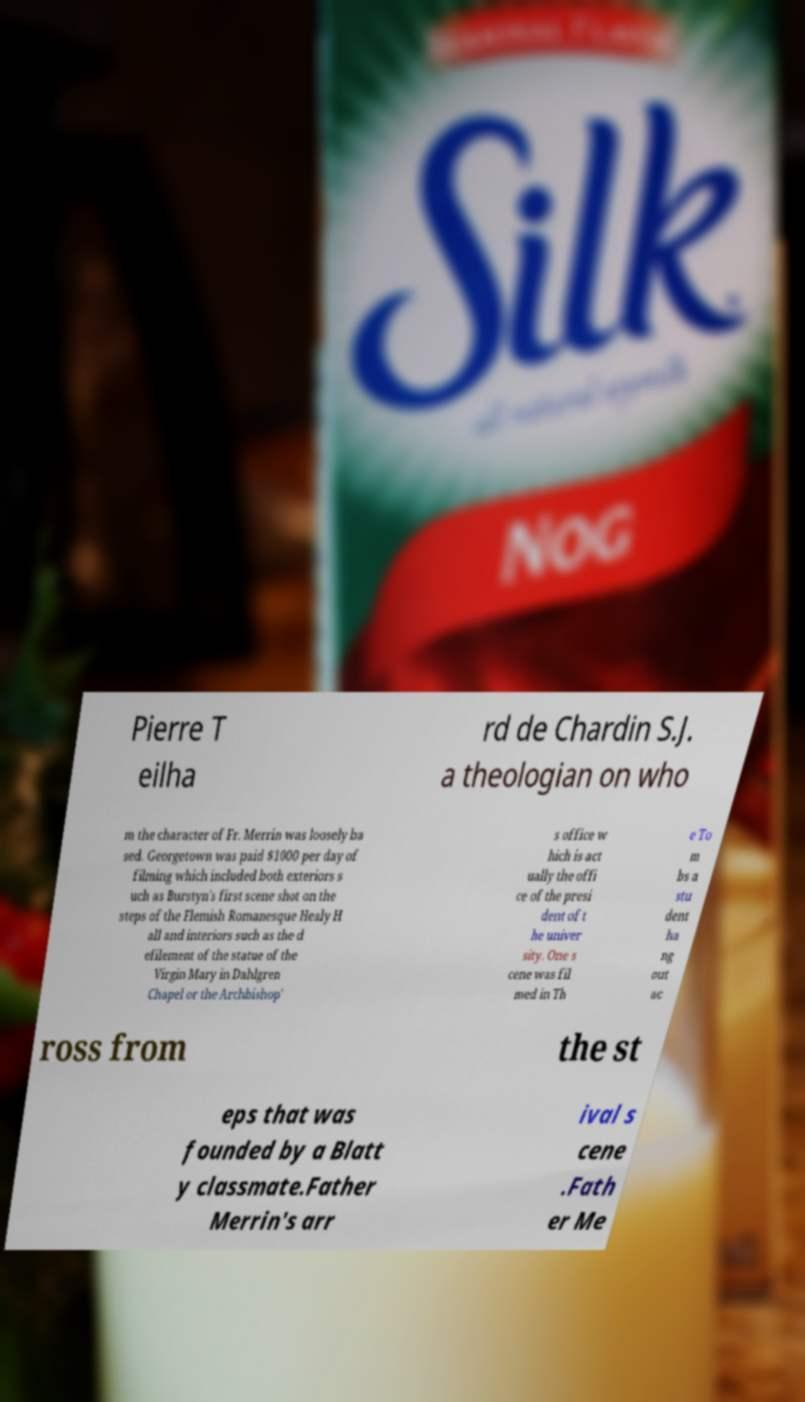Could you extract and type out the text from this image? Pierre T eilha rd de Chardin S.J. a theologian on who m the character of Fr. Merrin was loosely ba sed. Georgetown was paid $1000 per day of filming which included both exteriors s uch as Burstyn's first scene shot on the steps of the Flemish Romanesque Healy H all and interiors such as the d efilement of the statue of the Virgin Mary in Dahlgren Chapel or the Archbishop' s office w hich is act ually the offi ce of the presi dent of t he univer sity. One s cene was fil med in Th e To m bs a stu dent ha ng out ac ross from the st eps that was founded by a Blatt y classmate.Father Merrin's arr ival s cene .Fath er Me 